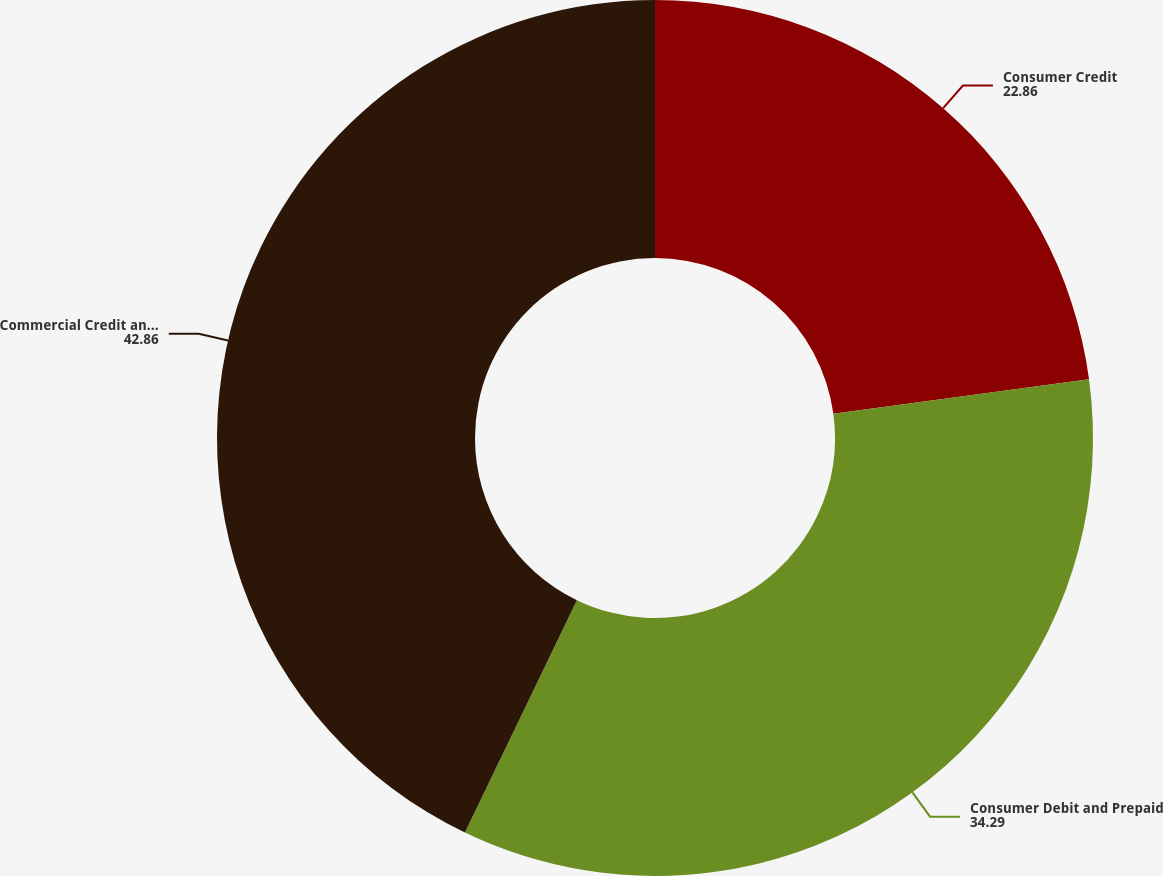Convert chart to OTSL. <chart><loc_0><loc_0><loc_500><loc_500><pie_chart><fcel>Consumer Credit<fcel>Consumer Debit and Prepaid<fcel>Commercial Credit and Debit<nl><fcel>22.86%<fcel>34.29%<fcel>42.86%<nl></chart> 